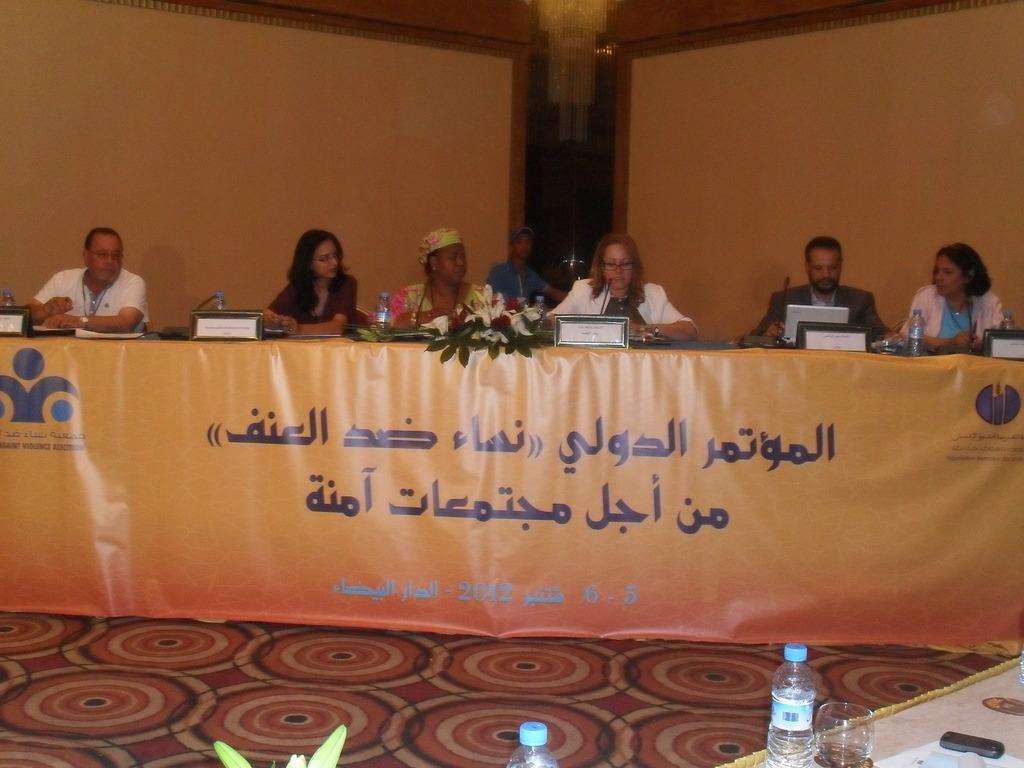Please provide a concise description of this image. In this image, we can see group of people are sat on the chairs. In-front of them, there is a desk, that is covered with banner, few items are placed on it. At the bottom, we can see some table, bottle, glasses, plant,mobile, papers on the table and floor. At background, we can see chandelier and walls. 